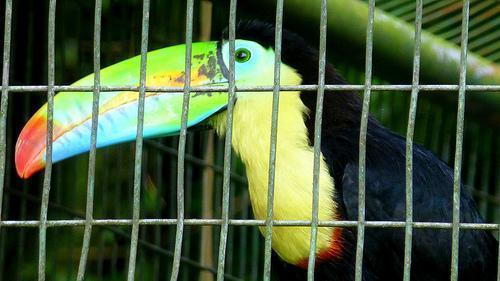How many birds are there?
Give a very brief answer. 1. 